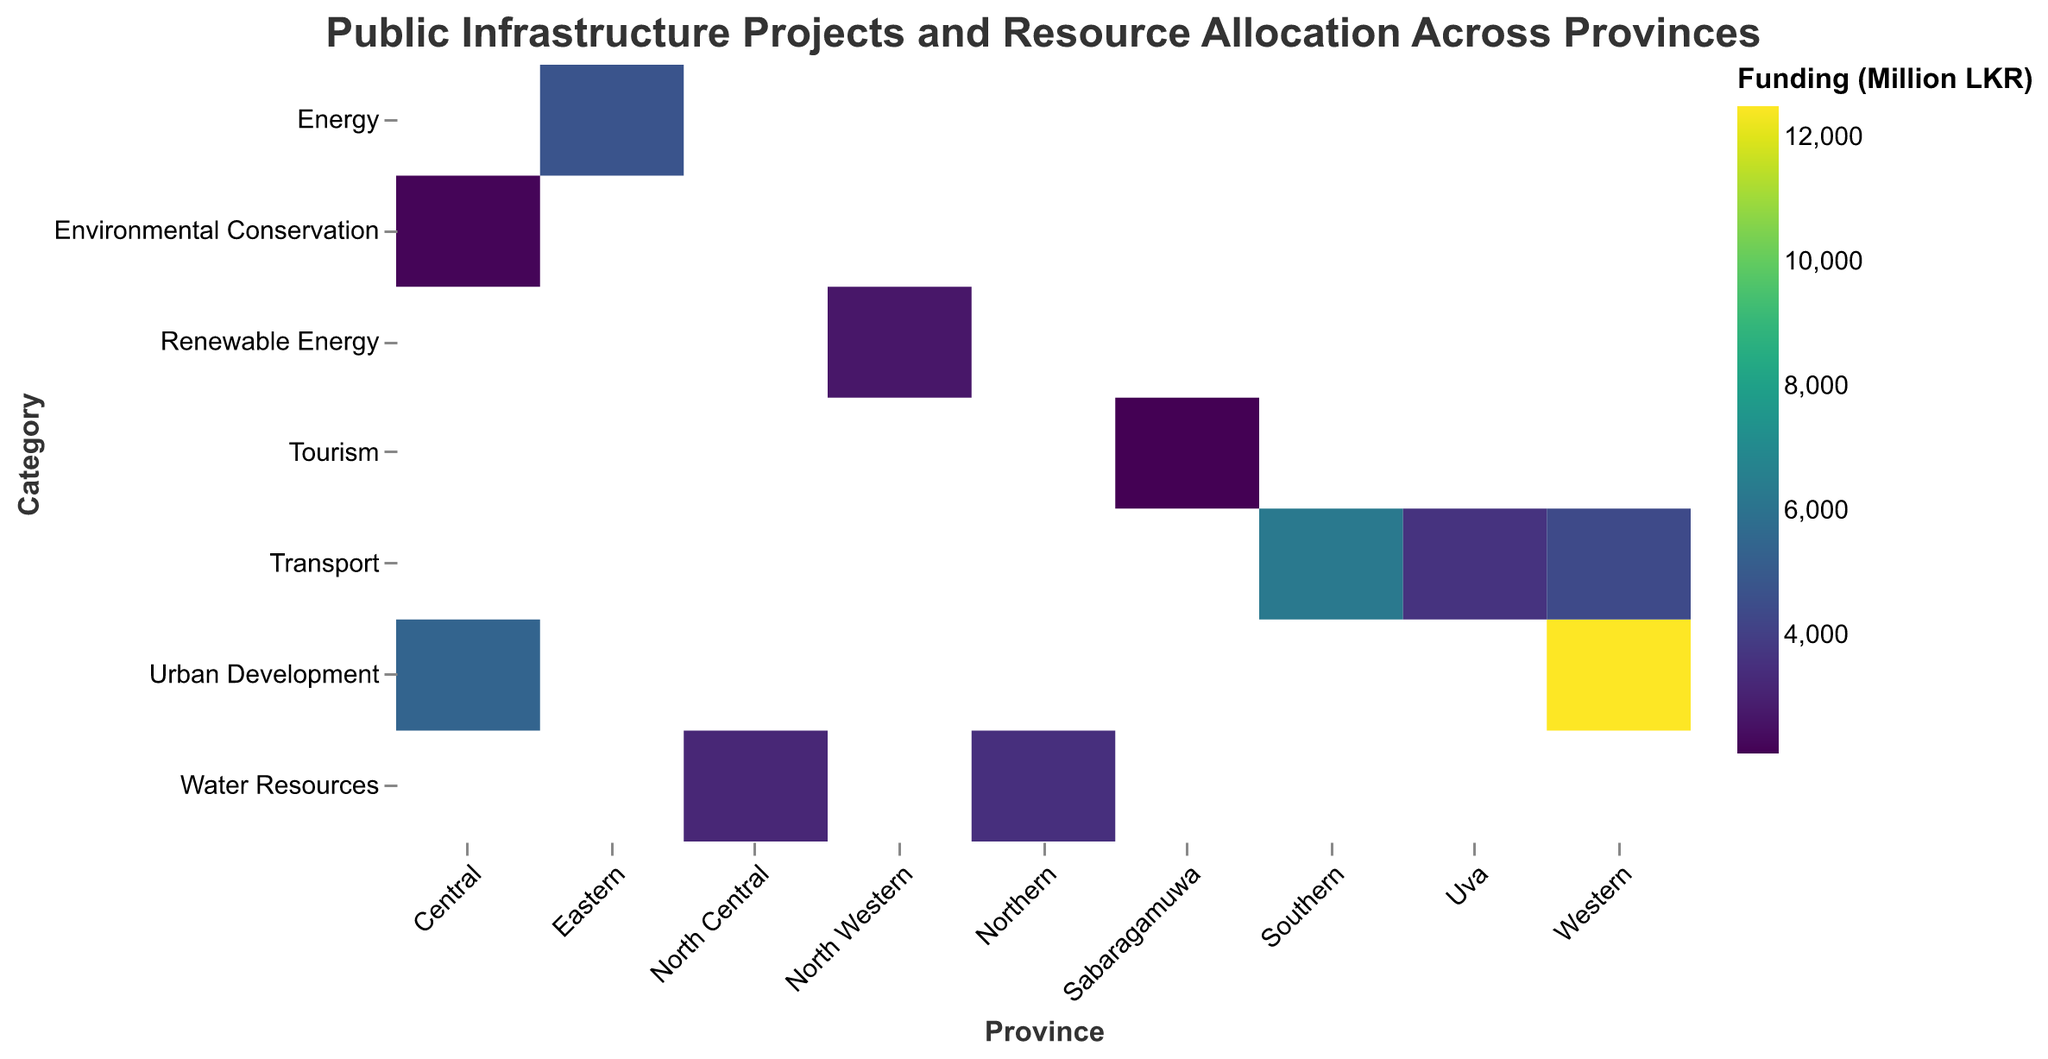Which province has the highest funding allocation for projects? By looking at the color scale and intensity, Western province has the darkest color indicating the highest funding allocation, with the Colombo Port City project receiving 12,500 million LKR.
Answer: Western Which project in the Transport category received the most funding? By observing the intensity of colors within the Transport category, Hambantota Port in the Southern province has the darkest color and the highest funding allocation of 6,300 million LKR.
Answer: Hambantota Port What is the total funding allocated for Water Resources projects across all provinces? Adding the funding allocation for the Jaffna Water Supply Scheme (3,500 million LKR) and Anuradhapura Water Distribution (3,200 million LKR) results in a total of 6,700 million LKR for Water Resources projects.
Answer: 6,700 million LKR Which category received the least funding in the Central province? In the Central province, the Nuwara Eliya Biodiversity Park categorized under Environmental Conservation has the lightest color indicating the lowest funding of 2,200 million LKR compared to the Kandy Megapolis project in Urban Development with 5,400 million LKR.
Answer: Environmental Conservation How does the funding for the Puttalam Wind Farm compare to the funding for the Ratnapura Gem Museum? Comparing the color intensities and funding allocations, the Puttalam Wind Farm (2,700 million LKR) in Renewable Energy has a higher allocation than the Ratnapura Gem Museum (2,100 million LKR) in Tourism.
Answer: Puttalam Wind Farm has higher funding Which transport project has a higher funding allocation, Badulla – Ella Rail Extension or Kelaniya Bridge Development? The Kelaniya Bridge Development project in the Western province (4,400 million LKR) has a darker color and a higher funding allocation compared to the Badulla – Ella Rail Extension in the Uva province (3,600 million LKR).
Answer: Kelaniya Bridge Development Does any province have more than one project listed? If so, which one(s)? By looking at the provinces along the x-axis, Western province is the only one with more than one project listed—Colombo Port City and Kelaniya Bridge Development.
Answer: Western What is the average funding allocation for projects in the Western province? The Western province has two projects: Colombo Port City (12,500 million LKR) and Kelaniya Bridge Development (4,400 million LKR). The average funding allocation is calculated as (12,500 + 4,400) / 2 = 8,450 million LKR.
Answer: 8,450 million LKR Which category appears to have the most balanced distribution of funding allocations across different provinces? Explain. By observing the heatmap, the Transport category appears to have a relatively balanced distribution of funding across provinces (Hambantota Port - 6,300 million LKR, Badulla – Ella Rail Extension - 3,600 million LKR, and Kelaniya Bridge Development - 4,400 million LKR), with no single project dominating the funding entirely.
Answer: Transport 